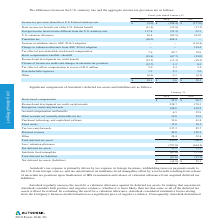According to Autodesk's financial document, What is Autodesk's tax expense primarily driven by? Autodesk’s tax expense is primarily driven by tax expense in foreign locations, withholding taxes on payments made to the U.S. from foreign sources, and tax amortization on indefinite-lived intangibles offset by a tax benefit resulting from release of uncertain tax positions upon finalization of IRS examination and release of valuation allowance from acquired deferred tax liabilities.. The document states: "Autodesk’s tax expense is primarily driven by tax expense in foreign locations, withholding taxes on payments made to the U.S. from foreign sources, a..." Also, What was the deferred revenue for as of January 31, 2019? According to the financial document, 49.0 (in millions). The relevant text states: "ax loss carryforwards 237.2 85.7 Deferred revenue 49.0 120.3 Other 28.4 32.4 Total deferred tax assets 850.9 706.3 Less: valuation allowance (797.8) (634...." Also, What were the fixed assets in 2018? According to the financial document, 16.5 (in millions). The relevant text states: "capitalized software 32.6 43.4 Fixed assets 15.0 16.5 Tax loss carryforwards 237.2 85.7 Deferred revenue 49.0 120.3 Other 28.4 32.4 Total deferred tax as..." Also, can you calculate: What is the change in the total deferred tax assets from 2018 to 2019? Based on the calculation: 850.9-706.3, the result is 144.6 (in millions). This is based on the information: "0 120.3 Other 28.4 32.4 Total deferred tax assets 850.9 706.3 Less: valuation allowance (797.8) (634.2) Net deferred tax assets 53.1 72.1 Indefinite lived 3 Other 28.4 32.4 Total deferred tax assets 8..." The key data points involved are: 706.3, 850.9. Also, can you calculate: What is the change in stock-based compensation from 2018 to 2019? Based on the calculation: $26.7-$25.9, the result is 0.8 (in millions). This is based on the information: "2019 2018 Stock-based compensation $ 25.9 $ 26.7 Research and development tax credit carryforwards 238.7 170.3 Foreign tax credit carryforwar 2019 2018 Stock-based compensation $ 25.9 $ 26.7 Research ..." The key data points involved are: 25.9, 26.7. Also, can you calculate: What is the average stock-based compensation for the three year period from 2018 to 2019? To answer this question, I need to perform calculations using the financial data. The calculation is: (25.9+26.7)/2 , which equals 26.3 (in millions). This is based on the information: "2019 2018 Stock-based compensation $ 25.9 $ 26.7 Research and development tax credit carryforwards 238.7 170.3 Foreign tax credit carryforwar 2019 2018 Stock-based compensation $ 25.9 $ 26.7 Research ..." The key data points involved are: 25.9, 26.7. 